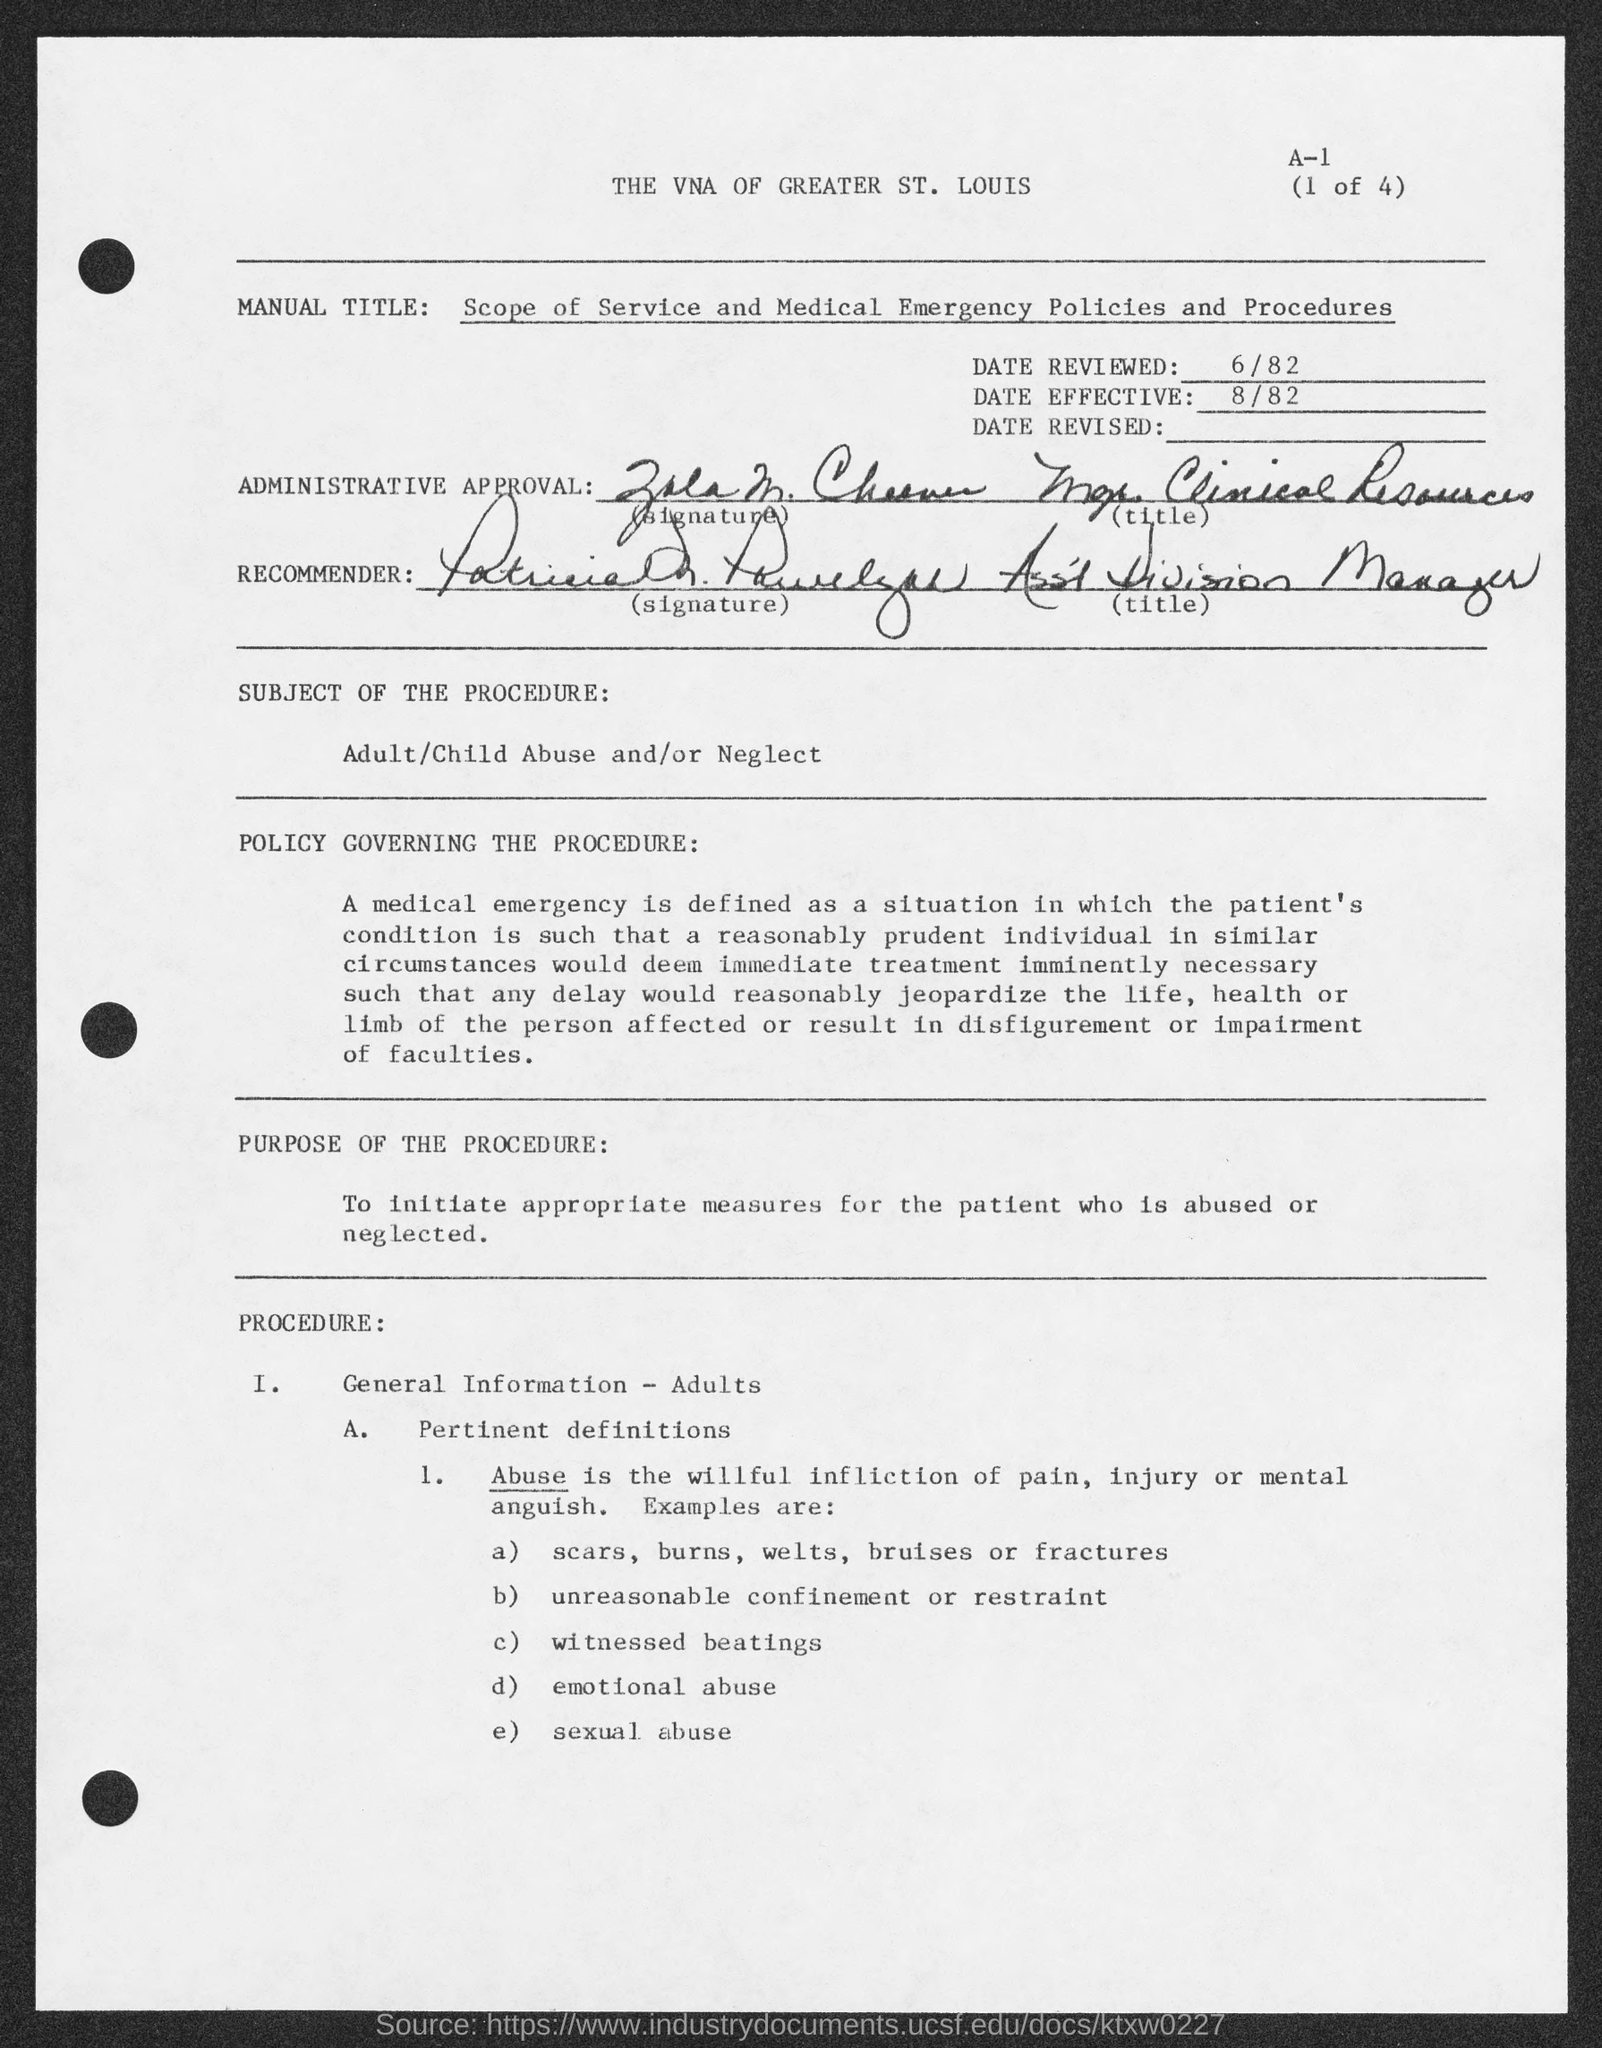Indicate a few pertinent items in this graphic. The general information was provided in the procedure for adults. The "Date Reviewed" refers to June 1982. What is the scope of service, medical emergency policies and procedures, and manual title for <service being provided>? The purpose of the procedure for initiating appropriate measures for the patient who is abused or neglected is to ensure that the proper actions are taken to protect and support the patient in such situations. The subject of the procedure is defined as adult or child abuse and/or neglect. 